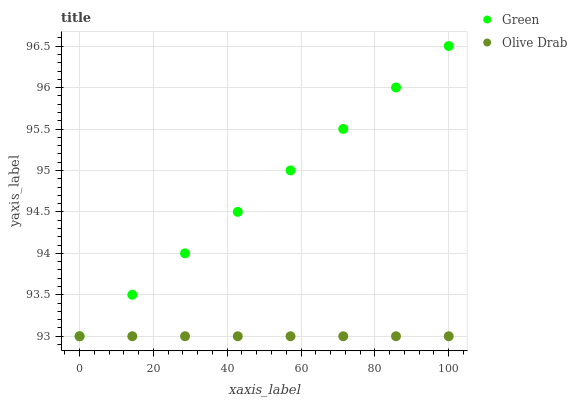Does Olive Drab have the minimum area under the curve?
Answer yes or no. Yes. Does Green have the maximum area under the curve?
Answer yes or no. Yes. Does Olive Drab have the maximum area under the curve?
Answer yes or no. No. Is Olive Drab the smoothest?
Answer yes or no. Yes. Is Green the roughest?
Answer yes or no. Yes. Is Olive Drab the roughest?
Answer yes or no. No. Does Green have the lowest value?
Answer yes or no. Yes. Does Green have the highest value?
Answer yes or no. Yes. Does Olive Drab have the highest value?
Answer yes or no. No. Does Green intersect Olive Drab?
Answer yes or no. Yes. Is Green less than Olive Drab?
Answer yes or no. No. Is Green greater than Olive Drab?
Answer yes or no. No. 